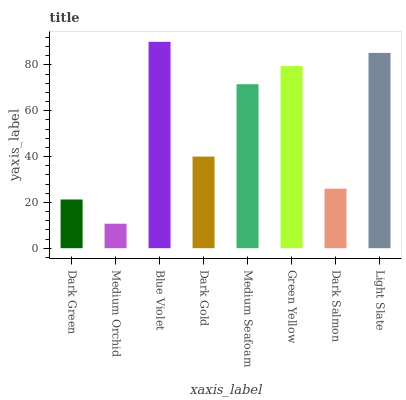Is Medium Orchid the minimum?
Answer yes or no. Yes. Is Blue Violet the maximum?
Answer yes or no. Yes. Is Blue Violet the minimum?
Answer yes or no. No. Is Medium Orchid the maximum?
Answer yes or no. No. Is Blue Violet greater than Medium Orchid?
Answer yes or no. Yes. Is Medium Orchid less than Blue Violet?
Answer yes or no. Yes. Is Medium Orchid greater than Blue Violet?
Answer yes or no. No. Is Blue Violet less than Medium Orchid?
Answer yes or no. No. Is Medium Seafoam the high median?
Answer yes or no. Yes. Is Dark Gold the low median?
Answer yes or no. Yes. Is Dark Green the high median?
Answer yes or no. No. Is Medium Orchid the low median?
Answer yes or no. No. 